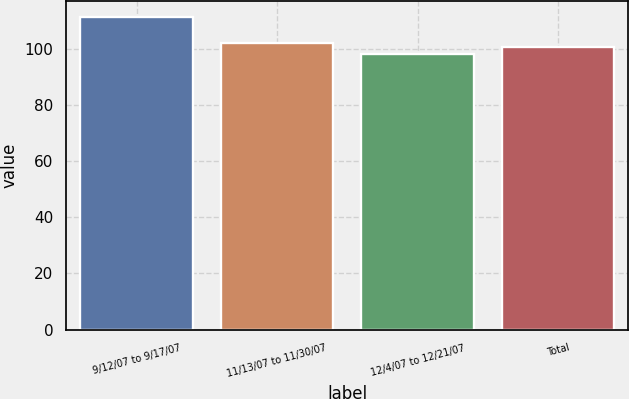Convert chart. <chart><loc_0><loc_0><loc_500><loc_500><bar_chart><fcel>9/12/07 to 9/17/07<fcel>11/13/07 to 11/30/07<fcel>12/4/07 to 12/21/07<fcel>Total<nl><fcel>111.6<fcel>102.24<fcel>98.2<fcel>100.9<nl></chart> 